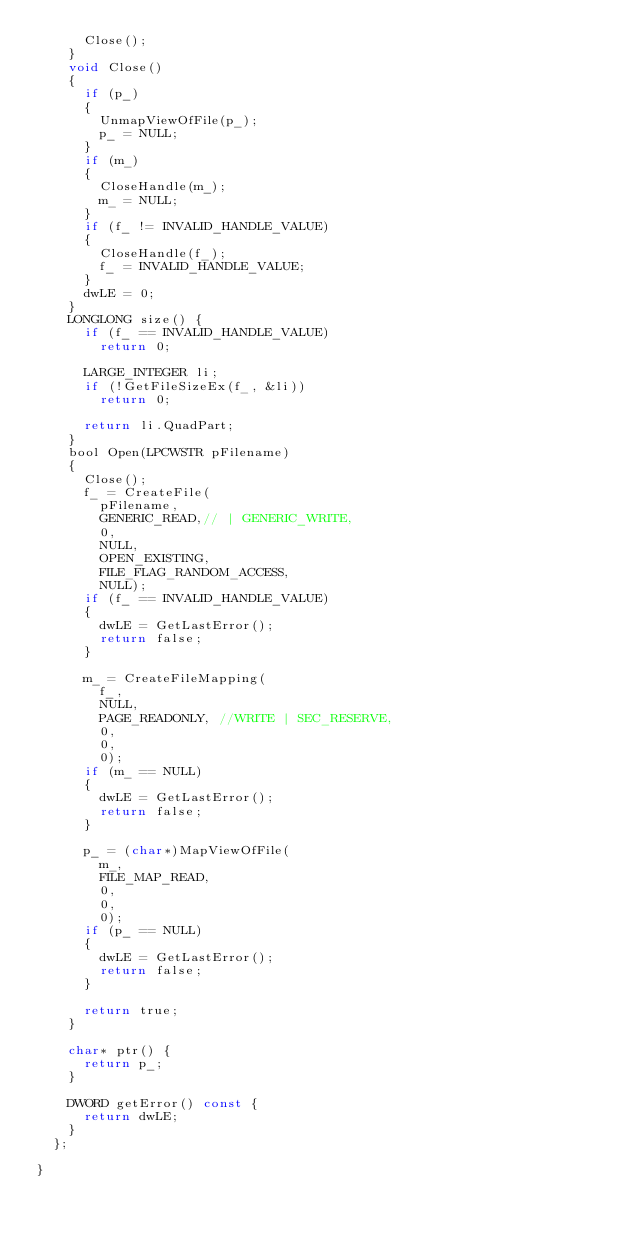<code> <loc_0><loc_0><loc_500><loc_500><_C_>			Close();
		}
		void Close()
		{
			if (p_)
			{
				UnmapViewOfFile(p_);
				p_ = NULL;
			}
			if (m_)
			{
				CloseHandle(m_);
				m_ = NULL;
			}
			if (f_ != INVALID_HANDLE_VALUE)
			{
				CloseHandle(f_);
				f_ = INVALID_HANDLE_VALUE;
			}
			dwLE = 0;
		}
		LONGLONG size() {
			if (f_ == INVALID_HANDLE_VALUE)
				return 0;

			LARGE_INTEGER li;
			if (!GetFileSizeEx(f_, &li))
				return 0;

			return li.QuadPart;
		}
		bool Open(LPCWSTR pFilename)
		{
			Close();
			f_ = CreateFile(
				pFilename,
				GENERIC_READ,// | GENERIC_WRITE, 
				0,
				NULL,
				OPEN_EXISTING,
				FILE_FLAG_RANDOM_ACCESS,
				NULL);
			if (f_ == INVALID_HANDLE_VALUE)
			{
				dwLE = GetLastError();
				return false;
			}

			m_ = CreateFileMapping(
				f_,
				NULL,
				PAGE_READONLY, //WRITE | SEC_RESERVE,
				0,
				0,
				0);
			if (m_ == NULL)
			{
				dwLE = GetLastError();
				return false;
			}

			p_ = (char*)MapViewOfFile(
				m_,
				FILE_MAP_READ,
				0,
				0,
				0);
			if (p_ == NULL)
			{
				dwLE = GetLastError();
				return false;
			}

			return true;
		}

		char* ptr() {
			return p_;
		}

		DWORD getError() const {
			return dwLE;
		}
	};

}</code> 